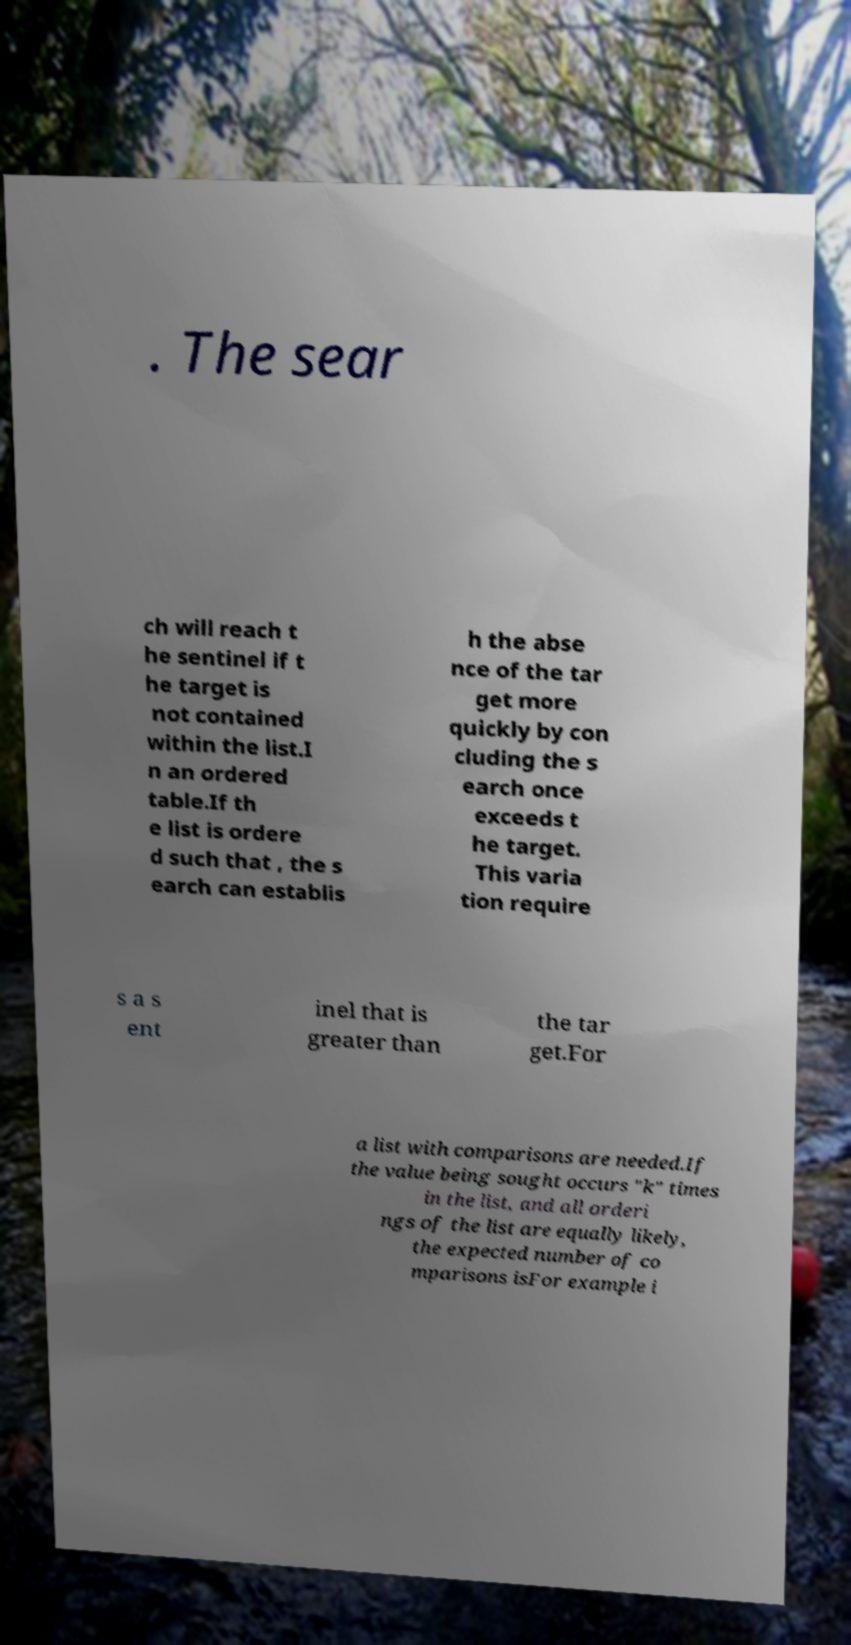I need the written content from this picture converted into text. Can you do that? . The sear ch will reach t he sentinel if t he target is not contained within the list.I n an ordered table.If th e list is ordere d such that , the s earch can establis h the abse nce of the tar get more quickly by con cluding the s earch once exceeds t he target. This varia tion require s a s ent inel that is greater than the tar get.For a list with comparisons are needed.If the value being sought occurs "k" times in the list, and all orderi ngs of the list are equally likely, the expected number of co mparisons isFor example i 